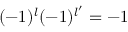Convert formula to latex. <formula><loc_0><loc_0><loc_500><loc_500>( - 1 ) ^ { l } ( - 1 ) ^ { l ^ { \prime } } = - 1</formula> 